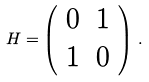Convert formula to latex. <formula><loc_0><loc_0><loc_500><loc_500>H = \left ( \begin{array} { c c } 0 & 1 \\ 1 & 0 \end{array} \right ) \, .</formula> 